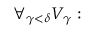<formula> <loc_0><loc_0><loc_500><loc_500>\forall _ { \gamma < \delta } { V _ { \gamma } \colon }</formula> 